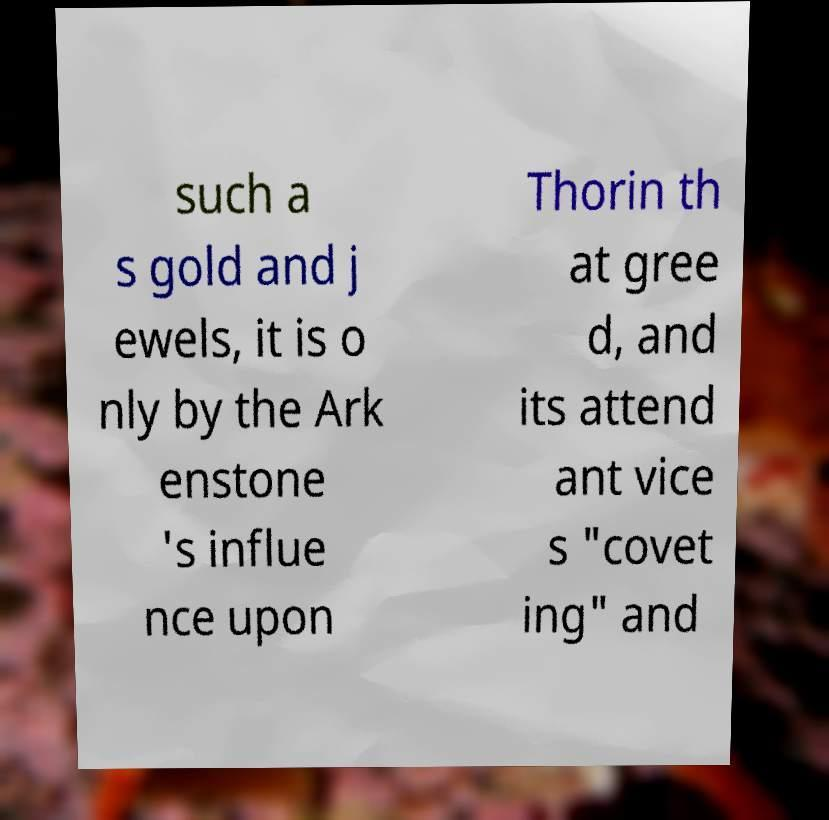Please identify and transcribe the text found in this image. such a s gold and j ewels, it is o nly by the Ark enstone 's influe nce upon Thorin th at gree d, and its attend ant vice s "covet ing" and 